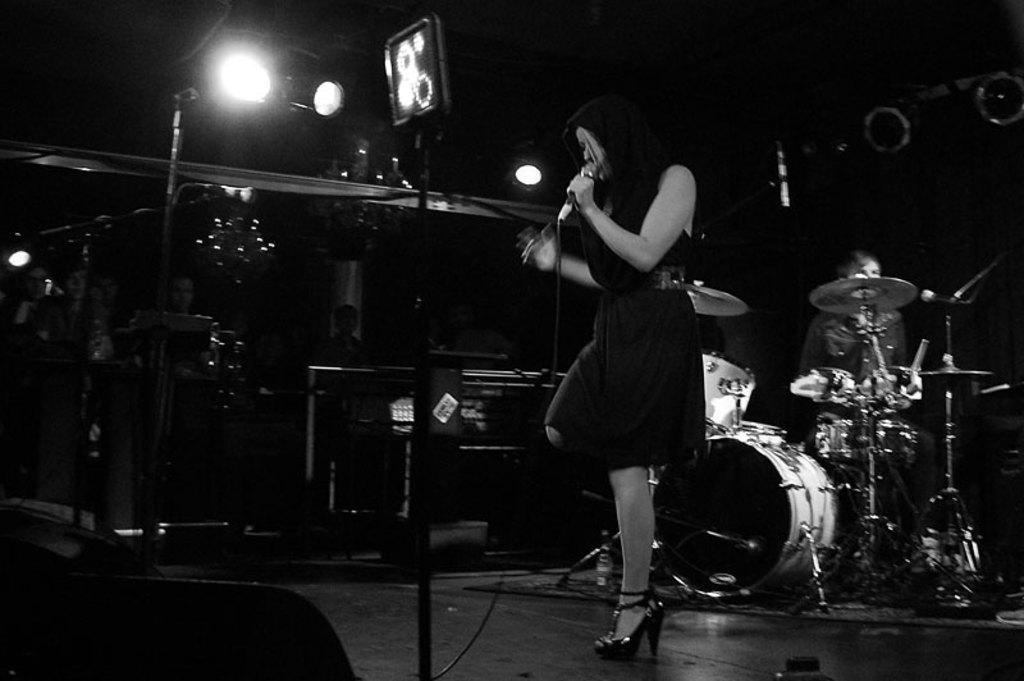In one or two sentences, can you explain what this image depicts? In the image in the center there is a lady holding microphone. she is singing, and back of her they were several musical instruments playing by musicians. And the left corner they were audience were watching over it. 